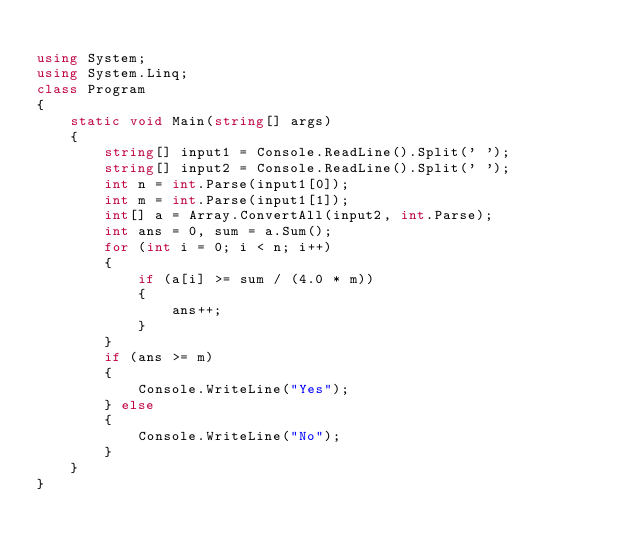Convert code to text. <code><loc_0><loc_0><loc_500><loc_500><_C#_>
using System;
using System.Linq;
class Program
{
    static void Main(string[] args)
    {
        string[] input1 = Console.ReadLine().Split(' ');
        string[] input2 = Console.ReadLine().Split(' ');
        int n = int.Parse(input1[0]);
        int m = int.Parse(input1[1]);
        int[] a = Array.ConvertAll(input2, int.Parse);
        int ans = 0, sum = a.Sum();
        for (int i = 0; i < n; i++)
        {
            if (a[i] >= sum / (4.0 * m))
            {
                ans++;
            }
        }
        if (ans >= m)
        {
            Console.WriteLine("Yes");
        } else
        {
            Console.WriteLine("No");
        }
    }
}
</code> 